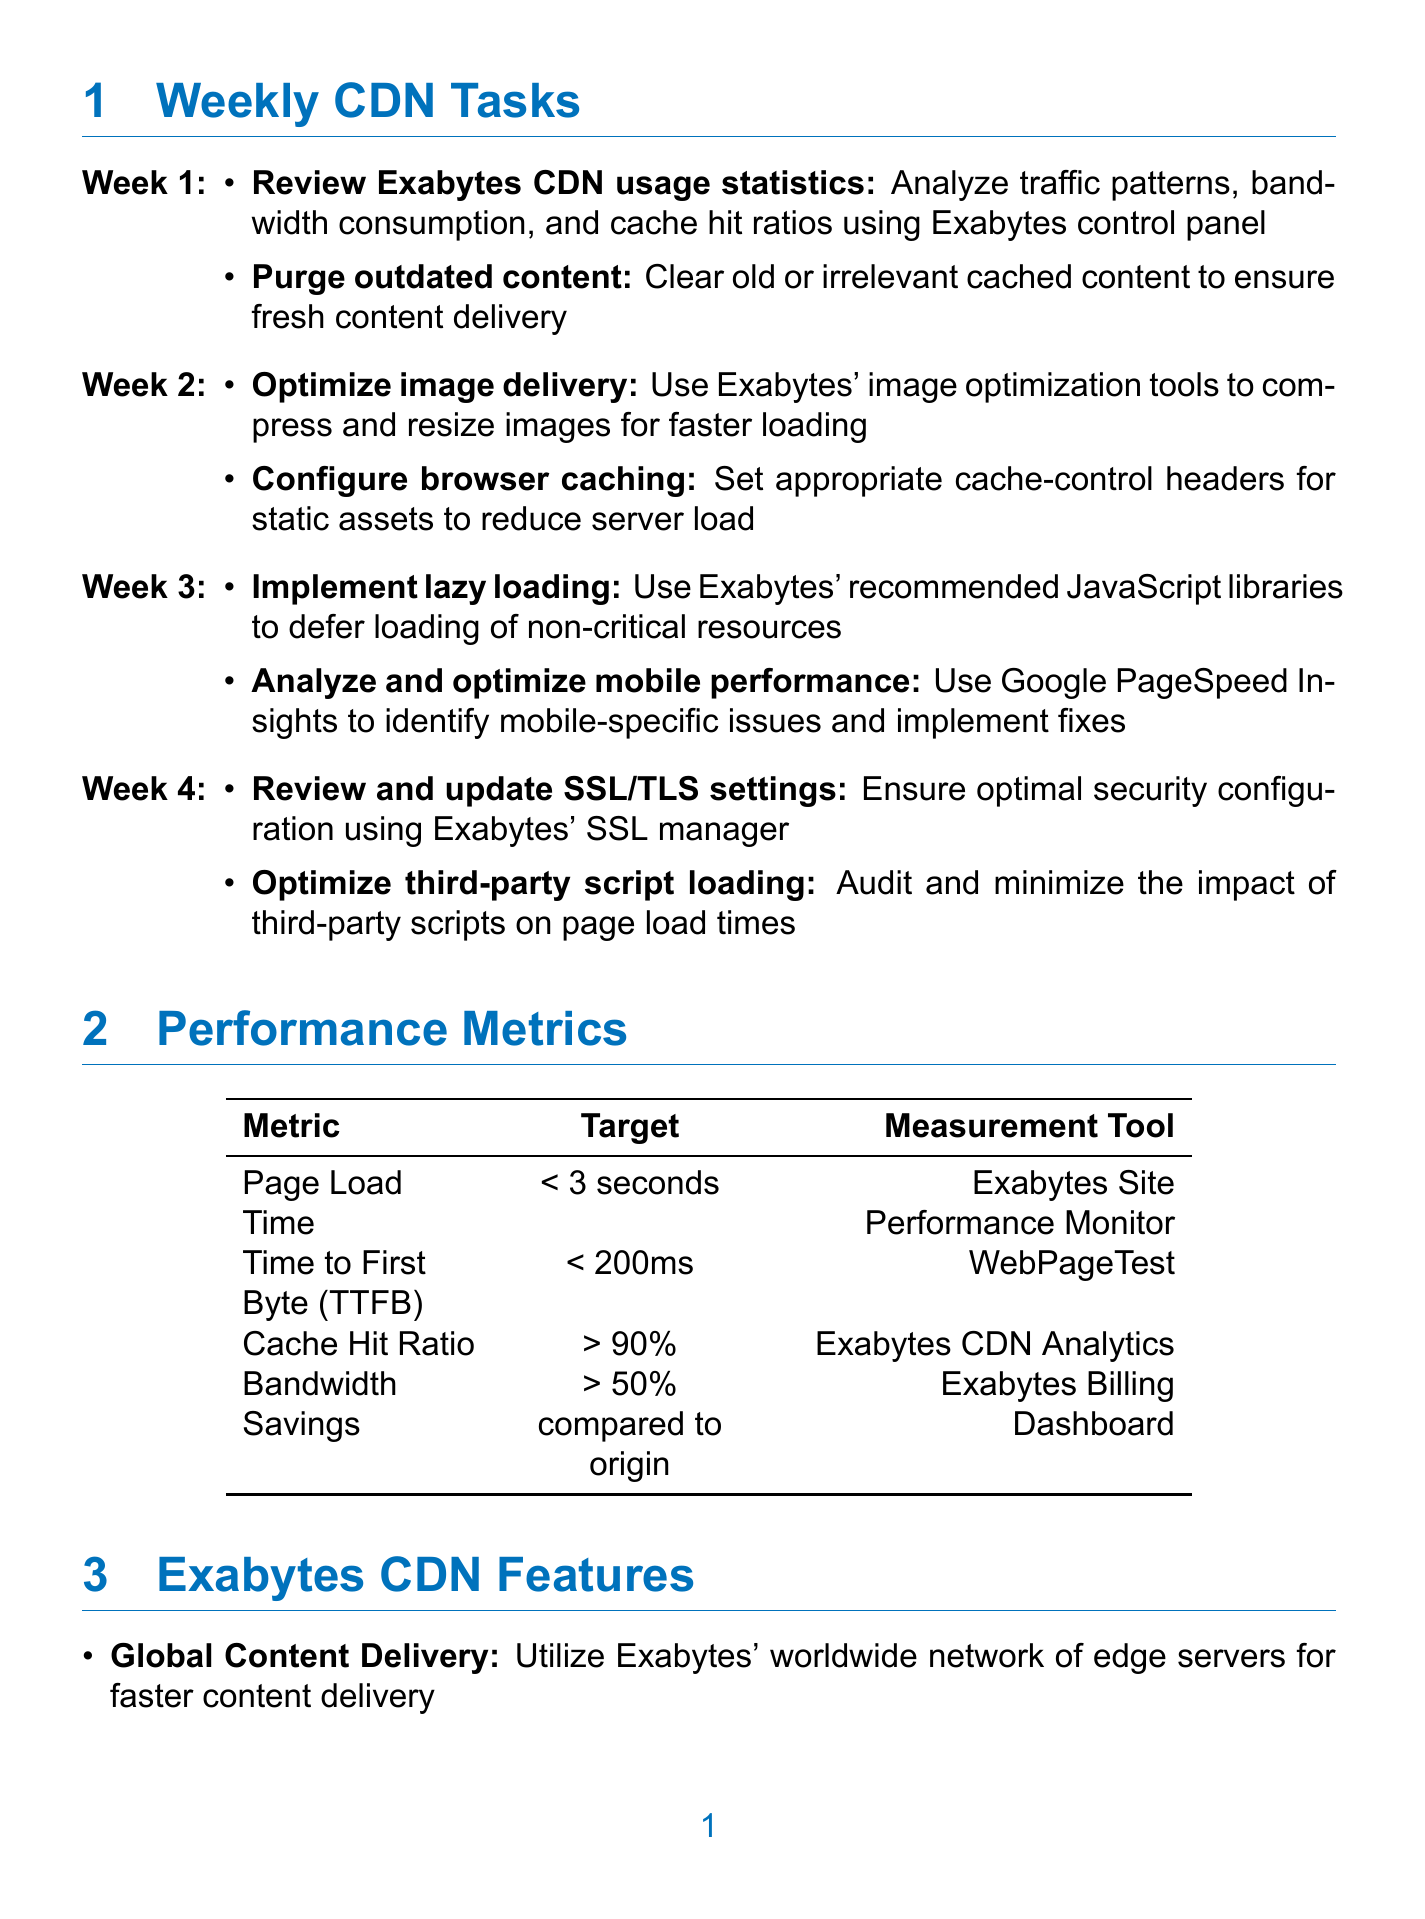what is the target for Page Load Time? The target for Page Load Time is specified in the performance metrics section of the document.
Answer: less than 3 seconds which tool is used to measure the Time to First Byte? The tool for measuring Time to First Byte is mentioned under the performance metrics section.
Answer: WebPageTest what is the task for week 1? The tasks for week 1 can be found in the weekly CDN tasks section.
Answer: Review Exabytes CDN usage statistics, Purge outdated content which CDN feature helps to prevent DDoS attacks? The document states specific features of the Exabytes CDN that include DDoS Protection.
Answer: DDoS Protection what is the target for Cache Hit Ratio? The target for Cache Hit Ratio is listed in the performance metrics section.
Answer: greater than 90 percent how many optimization tasks are listed for week 3? The number of optimization tasks for week 3 can be deduced from the weekly tasks section.
Answer: 2 which tool is described as having automatic CSS and JavaScript minification? The tool with automatic CSS and JavaScript minification is mentioned in the optimization tools section.
Answer: Exabytes Website Accelerator what is the target for Bandwidth Savings? The target for Bandwidth Savings is specified in the performance metrics section.
Answer: greater than 50 percent compared to origin 